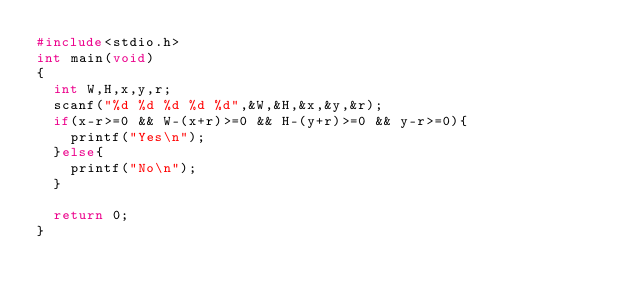<code> <loc_0><loc_0><loc_500><loc_500><_C_>#include<stdio.h>
int main(void)
{
	int W,H,x,y,r;
	scanf("%d %d %d %d %d",&W,&H,&x,&y,&r);
	if(x-r>=0 && W-(x+r)>=0 && H-(y+r)>=0 && y-r>=0){
		printf("Yes\n");
	}else{
		printf("No\n");
	}
	
	return 0;
}</code> 